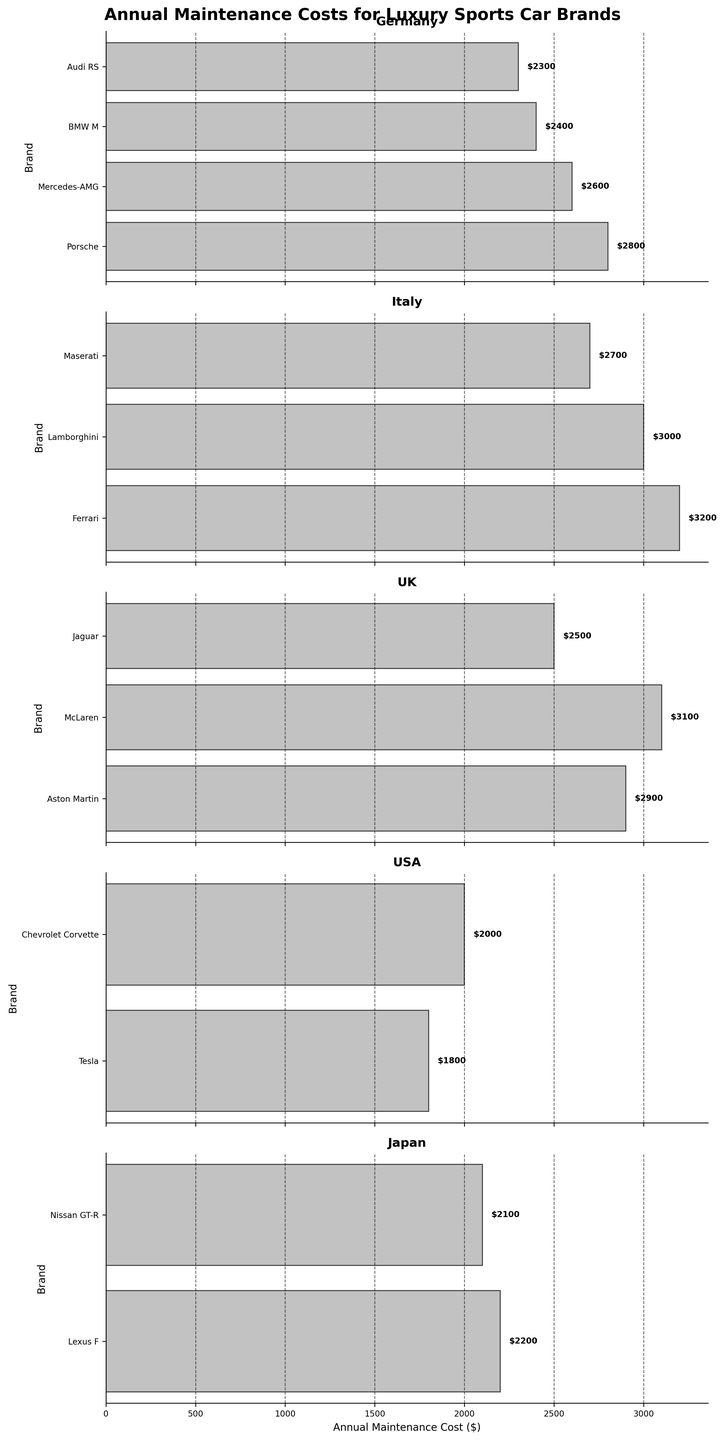Which country has the highest average annual maintenance cost? Calculate the average annual maintenance cost for each country, then compare the averages. Germany's average = (2800+2600+2400+2300)/4 = 2525, Italy's average = (3200+3000+2700)/3 = 2966.67, UK's average = (2900+3100+2500)/3 = 2833.33, USA's average = (1800+2000)/2 = 1900, Japan's average = (2200+2100)/2 = 2150. Italy has the highest average.
Answer: Italy Which German brand has the lowest annual maintenance cost? Compare the values for the German brands: Porsche ($2800), Mercedes-AMG ($2600), BMW M ($2400), Audi RS ($2300). Audi RS has the lowest cost.
Answer: Audi RS What's the difference in annual maintenance costs between the highest and lowest German brands? The highest German brand is Porsche ($2800) and the lowest is Audi RS ($2300). Difference = 2800 - 2300 = 500.
Answer: $500 How does the annual maintenance cost of McLaren compare to Porsche? Check the chart for McLaren and Porsche: McLaren ($3100), Porsche ($2800). McLaren's cost is $300 higher than Porsche.
Answer: $300 higher Which country features brands with the most varied annual maintenance costs? Evaluate the ranges within each country by subtracting the lowest value from the highest. For Germany: 2800 - 2300 = 500, Italy: 3200 - 2700 = 500, UK: 3100 - 2500 = 600, USA: 2000 - 1800 = 200, Japan: 2200 - 2100 = 100. The UK has the most varied costs.
Answer: UK Is there any country where all brands have an annual maintenance cost above $2500? Check each country's brand costs: Germany (2300–2800), Italy (2700–3200), UK (2500–3100), USA (1800–2000), Japan (2100–2200). Only Italy meets the criterion.
Answer: Italy Which country has the lowest average annual maintenance cost? Calculate the average for each country again and compare. Germany's average = 2525, Italy's average = 2966.67, UK's average = 2833.33, USA's average = 1900, Japan's average = 2150. USA has the lowest average.
Answer: USA What's the total annual maintenance cost for all the Japanese brands combined? Sum the costs of Japanese brands: Lexus F ($2200) + Nissan GT-R ($2100) = $4300.
Answer: $4300 